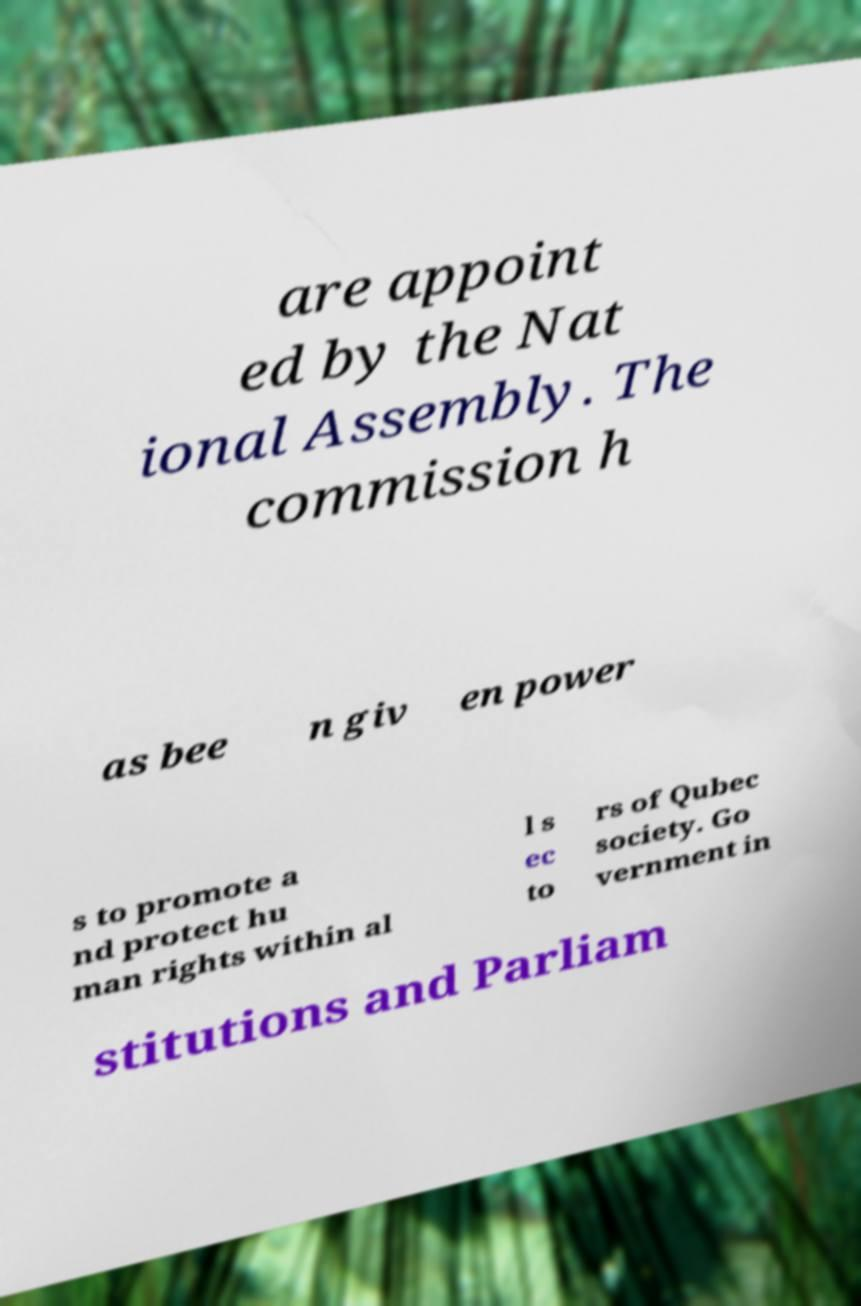Can you read and provide the text displayed in the image?This photo seems to have some interesting text. Can you extract and type it out for me? are appoint ed by the Nat ional Assembly. The commission h as bee n giv en power s to promote a nd protect hu man rights within al l s ec to rs of Qubec society. Go vernment in stitutions and Parliam 